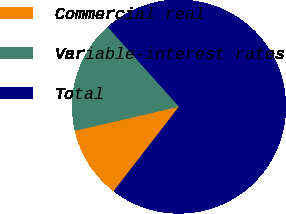Convert chart to OTSL. <chart><loc_0><loc_0><loc_500><loc_500><pie_chart><fcel>Commercial real<fcel>Variable-interest rates<fcel>Total<nl><fcel>10.89%<fcel>17.01%<fcel>72.1%<nl></chart> 